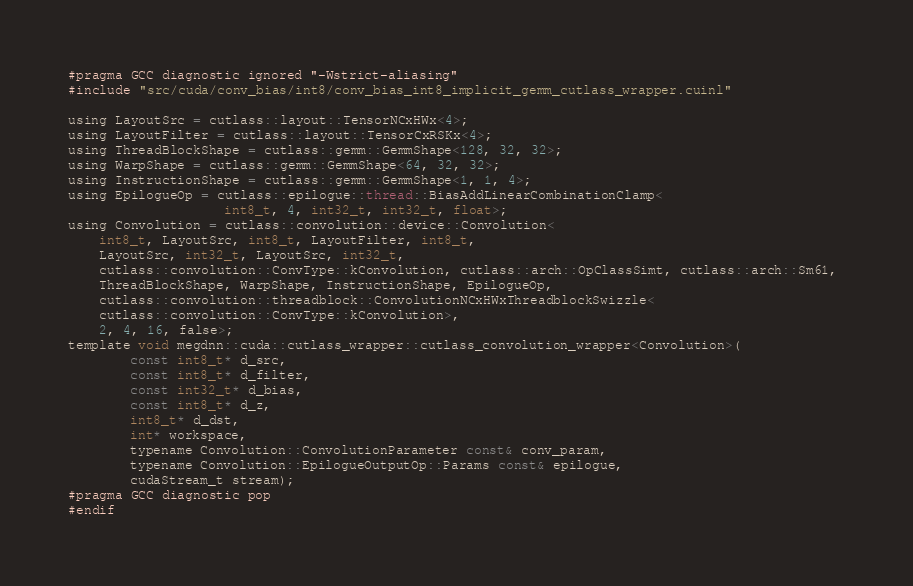Convert code to text. <code><loc_0><loc_0><loc_500><loc_500><_Cuda_>#pragma GCC diagnostic ignored "-Wstrict-aliasing"
#include "src/cuda/conv_bias/int8/conv_bias_int8_implicit_gemm_cutlass_wrapper.cuinl"

using LayoutSrc = cutlass::layout::TensorNCxHWx<4>;
using LayoutFilter = cutlass::layout::TensorCxRSKx<4>;
using ThreadBlockShape = cutlass::gemm::GemmShape<128, 32, 32>;
using WarpShape = cutlass::gemm::GemmShape<64, 32, 32>;
using InstructionShape = cutlass::gemm::GemmShape<1, 1, 4>;
using EpilogueOp = cutlass::epilogue::thread::BiasAddLinearCombinationClamp<
                    int8_t, 4, int32_t, int32_t, float>;
using Convolution = cutlass::convolution::device::Convolution<
    int8_t, LayoutSrc, int8_t, LayoutFilter, int8_t, 
    LayoutSrc, int32_t, LayoutSrc, int32_t, 
    cutlass::convolution::ConvType::kConvolution, cutlass::arch::OpClassSimt, cutlass::arch::Sm61, 
    ThreadBlockShape, WarpShape, InstructionShape, EpilogueOp, 
    cutlass::convolution::threadblock::ConvolutionNCxHWxThreadblockSwizzle<
    cutlass::convolution::ConvType::kConvolution>, 
    2, 4, 16, false>;
template void megdnn::cuda::cutlass_wrapper::cutlass_convolution_wrapper<Convolution>(
        const int8_t* d_src, 
        const int8_t* d_filter, 
        const int32_t* d_bias, 
        const int8_t* d_z, 
        int8_t* d_dst, 
        int* workspace, 
        typename Convolution::ConvolutionParameter const& conv_param, 
        typename Convolution::EpilogueOutputOp::Params const& epilogue, 
        cudaStream_t stream);
#pragma GCC diagnostic pop
#endif
</code> 